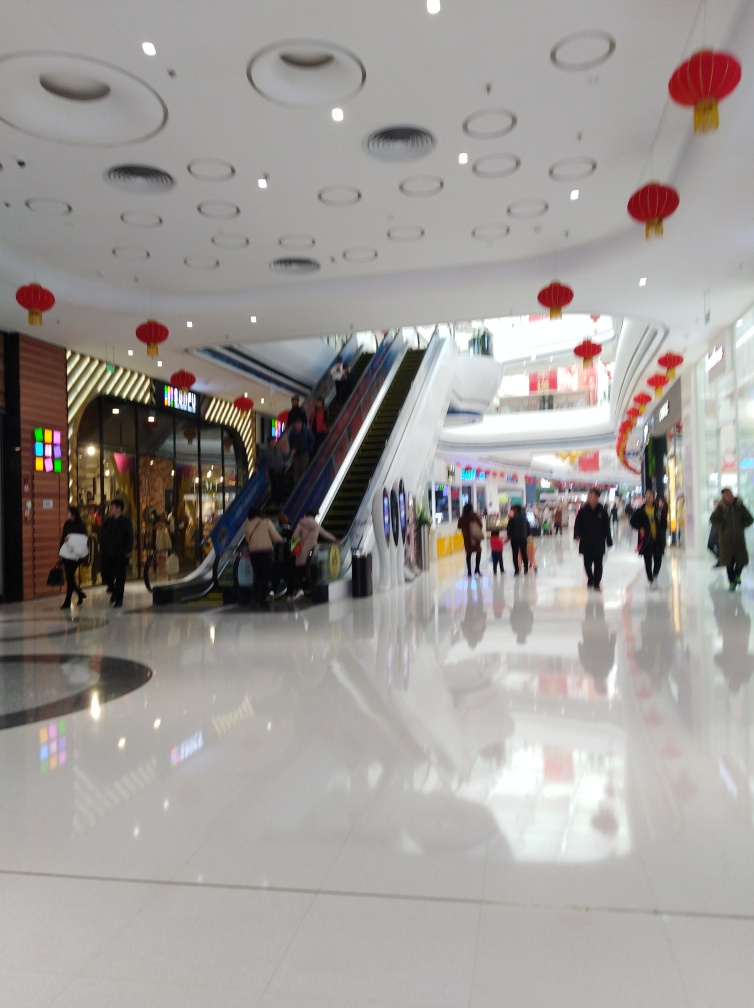Can you describe the atmosphere of the location depicted in the image? The image presents a lively and bustling indoor environment, likely a shopping mall, adorned with bright colors and decorations such as red lanterns suggesting a festive occasion. The reflective flooring enhances the vibrancy of the scene, and the presence of shoppers suggests a social and active setting. What could the red lanterns signify about the time of year or the location? Red lanterns are commonly associated with Chinese cultural celebrations and are often used during festivals such as the Chinese New Year. Their presence could imply that the image was taken during such a time or that the mall caters to a demographic that celebrates these traditions. 